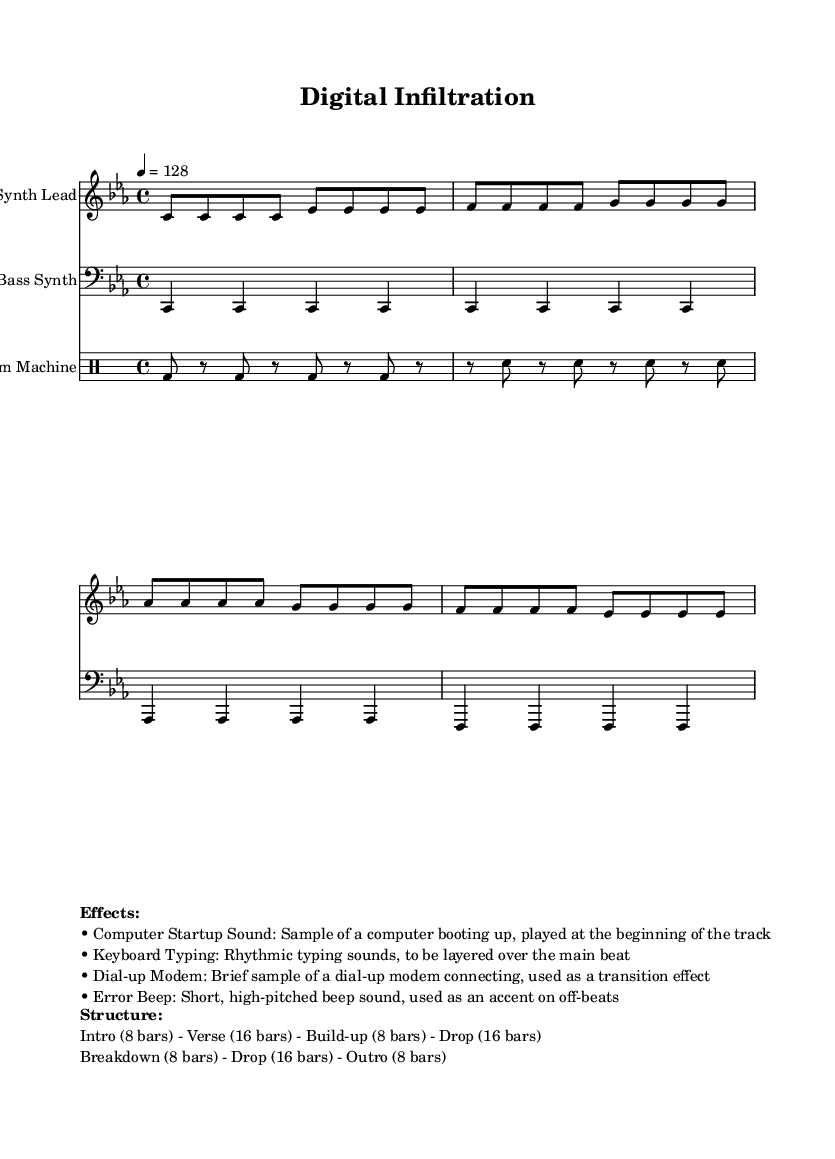What is the key signature of this music? The key signature shown in the global section indicates C minor, which includes three flats (B flat, E flat, and A flat).
Answer: C minor What is the time signature of this music? The time signature indicated in the global section is 4/4, signifying four beats per measure, and each beat is a quarter note.
Answer: 4/4 What is the tempo of this music? The tempo marking in the global section states 4 = 128, which denotes that there are 128 beats per minute.
Answer: 128 How many bars are in the intro section? The structure markup specifies that the intro section consists of 8 bars, as stated directly in the breakdown of the song structure.
Answer: 8 bars What are the effects used in this track? The markup lists several effects used in the track, including computer startup sound, keyboard typing, dial-up modem, and error beep, all designed to enhance the techno feel.
Answer: Computer startup sound, keyboard typing, dial-up modem, error beep What is the total number of bars in the drop section? The structure indicates that there are 16 bars in the drop section, making it the longest part of the song configuration that's clearly defined.
Answer: 16 bars What is one unique feature of this techno track? This track features samples of computer sounds and hacking-related audio effects, specifically noted as interesting audio characteristics that belong to the genre.
Answer: Computer sounds and hacking audio effects 